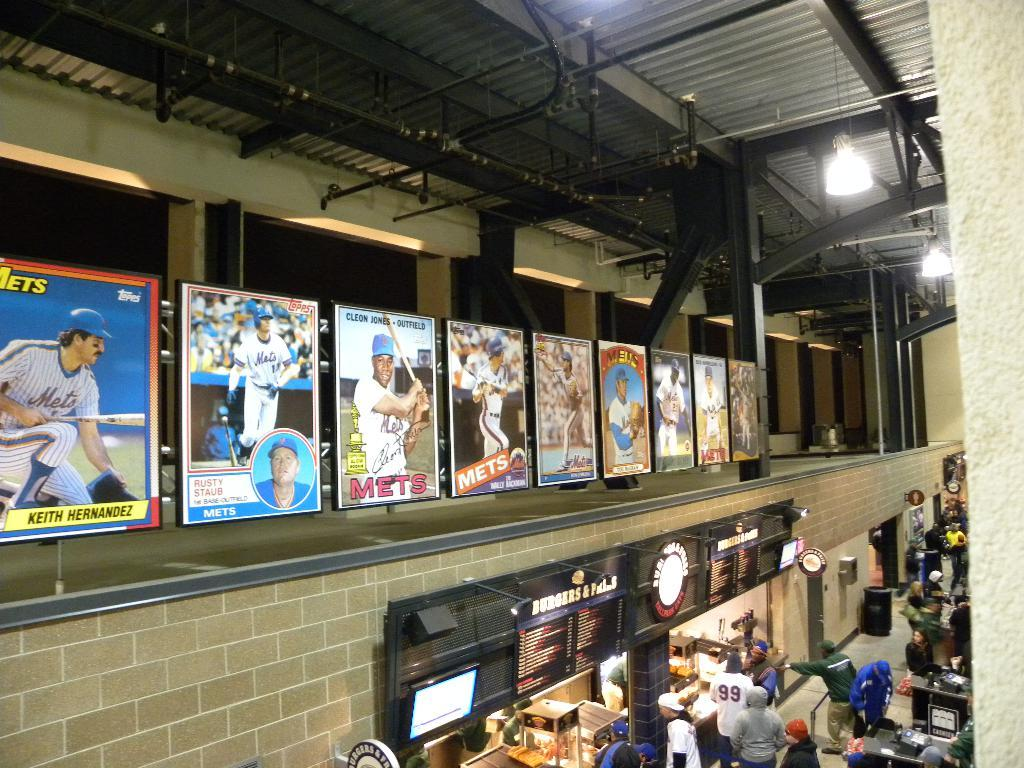Provide a one-sentence caption for the provided image. A cafeteria area with the ceiling showing and on the wall a line of large baseball cards with for MET players. 